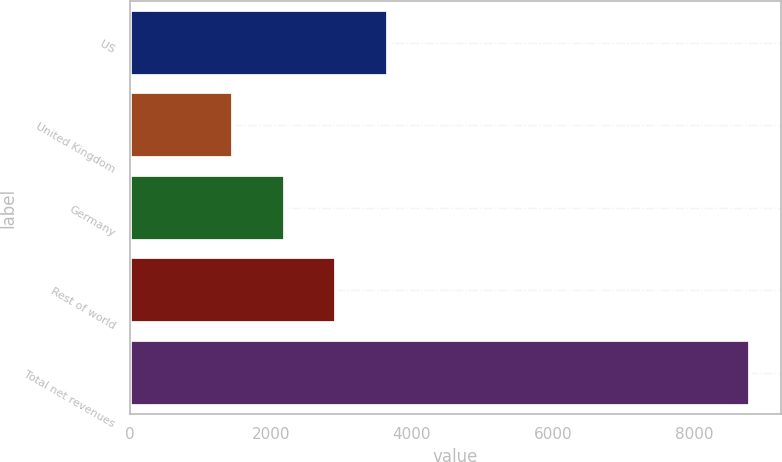Convert chart. <chart><loc_0><loc_0><loc_500><loc_500><bar_chart><fcel>US<fcel>United Kingdom<fcel>Germany<fcel>Rest of world<fcel>Total net revenues<nl><fcel>3661.8<fcel>1464<fcel>2196.6<fcel>2929.2<fcel>8790<nl></chart> 